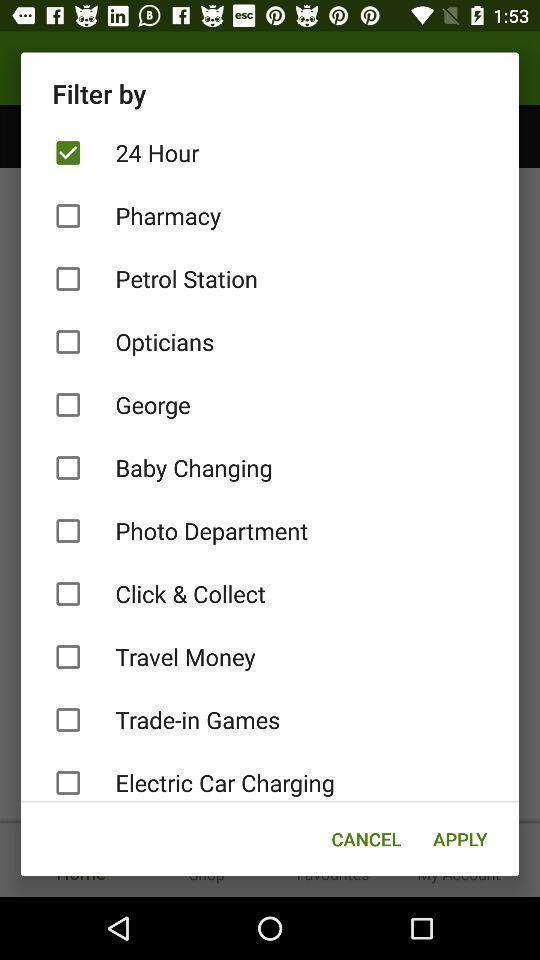Provide a description of this screenshot. Pop up page for selecting a filter for an app. 